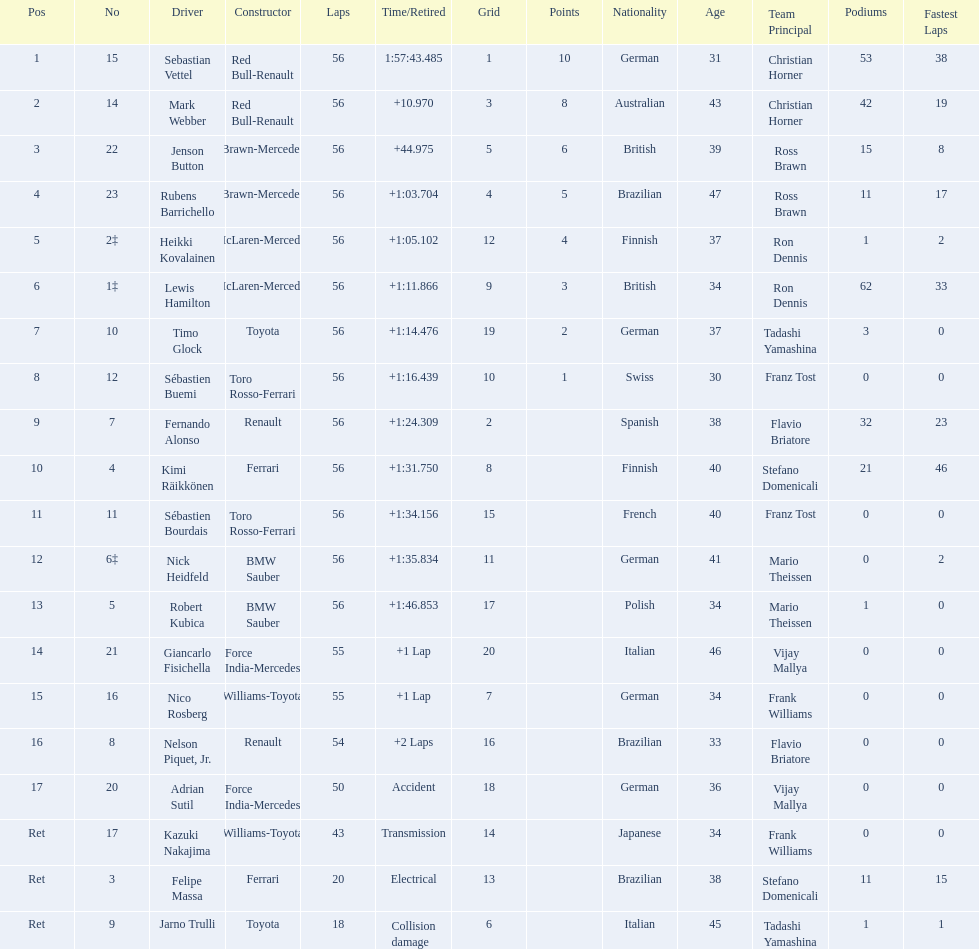Who was the slowest driver to finish the race? Robert Kubica. 